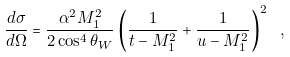<formula> <loc_0><loc_0><loc_500><loc_500>\frac { d \sigma } { d \Omega } = \frac { \alpha ^ { 2 } M _ { 1 } ^ { 2 } } { 2 \cos ^ { 4 } \theta _ { W } } \left ( \frac { 1 } { t - M _ { 1 } ^ { 2 } } + \frac { 1 } { u - M _ { 1 } ^ { 2 } } \right ) ^ { 2 } \ ,</formula> 